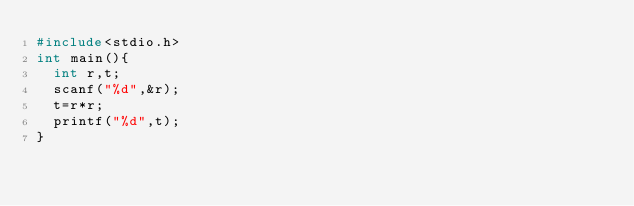Convert code to text. <code><loc_0><loc_0><loc_500><loc_500><_C_>#include<stdio.h>
int main(){
  int r,t;
  scanf("%d",&r);
  t=r*r;
  printf("%d",t);
}</code> 